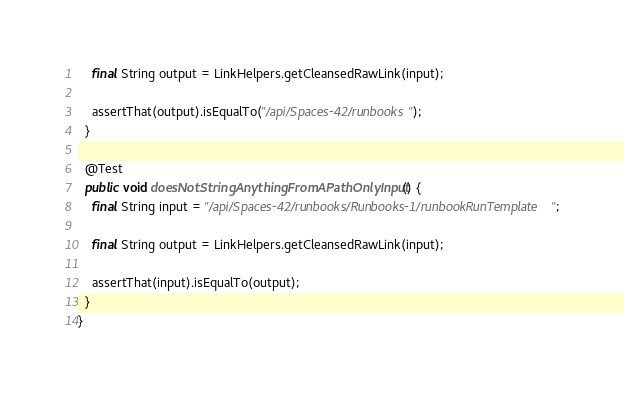Convert code to text. <code><loc_0><loc_0><loc_500><loc_500><_Java_>    final String output = LinkHelpers.getCleansedRawLink(input);

    assertThat(output).isEqualTo("/api/Spaces-42/runbooks");
  }

  @Test
  public void doesNotStringAnythingFromAPathOnlyInput() {
    final String input = "/api/Spaces-42/runbooks/Runbooks-1/runbookRunTemplate";

    final String output = LinkHelpers.getCleansedRawLink(input);

    assertThat(input).isEqualTo(output);
  }
}
</code> 